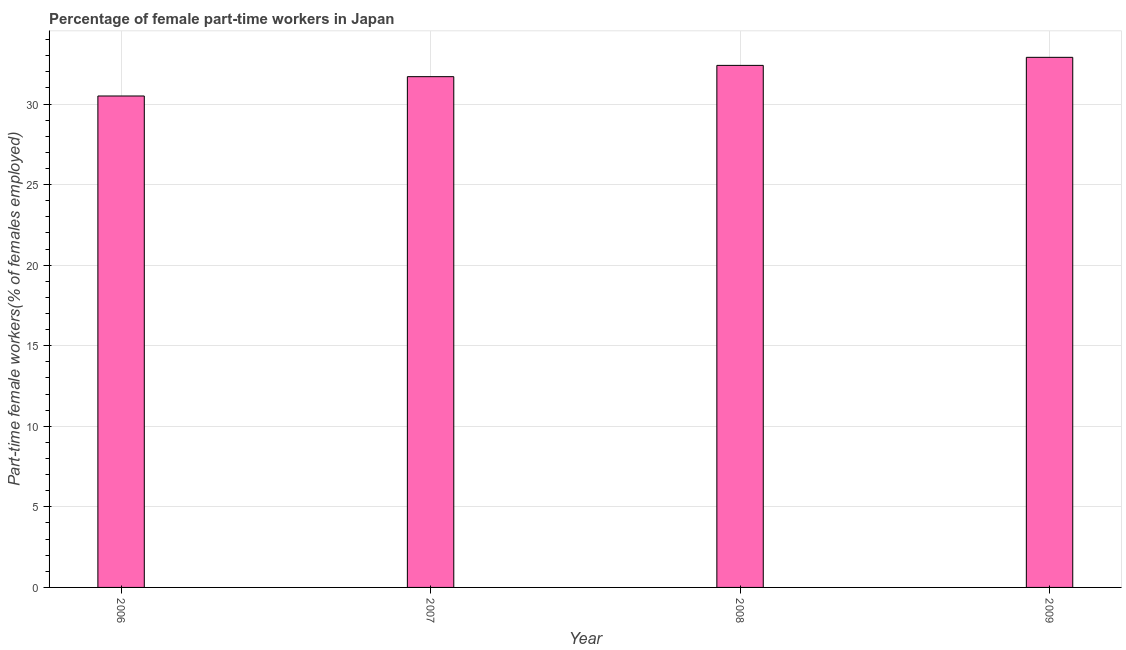Does the graph contain any zero values?
Make the answer very short. No. What is the title of the graph?
Ensure brevity in your answer.  Percentage of female part-time workers in Japan. What is the label or title of the X-axis?
Your answer should be compact. Year. What is the label or title of the Y-axis?
Offer a terse response. Part-time female workers(% of females employed). What is the percentage of part-time female workers in 2008?
Offer a very short reply. 32.4. Across all years, what is the maximum percentage of part-time female workers?
Keep it short and to the point. 32.9. Across all years, what is the minimum percentage of part-time female workers?
Give a very brief answer. 30.5. In which year was the percentage of part-time female workers minimum?
Your response must be concise. 2006. What is the sum of the percentage of part-time female workers?
Your response must be concise. 127.5. What is the average percentage of part-time female workers per year?
Keep it short and to the point. 31.88. What is the median percentage of part-time female workers?
Provide a short and direct response. 32.05. In how many years, is the percentage of part-time female workers greater than 27 %?
Offer a very short reply. 4. What is the difference between the highest and the second highest percentage of part-time female workers?
Your response must be concise. 0.5. Is the sum of the percentage of part-time female workers in 2006 and 2008 greater than the maximum percentage of part-time female workers across all years?
Give a very brief answer. Yes. What is the difference between the highest and the lowest percentage of part-time female workers?
Give a very brief answer. 2.4. In how many years, is the percentage of part-time female workers greater than the average percentage of part-time female workers taken over all years?
Provide a succinct answer. 2. How many bars are there?
Provide a succinct answer. 4. Are the values on the major ticks of Y-axis written in scientific E-notation?
Provide a short and direct response. No. What is the Part-time female workers(% of females employed) in 2006?
Provide a succinct answer. 30.5. What is the Part-time female workers(% of females employed) of 2007?
Make the answer very short. 31.7. What is the Part-time female workers(% of females employed) in 2008?
Offer a terse response. 32.4. What is the Part-time female workers(% of females employed) in 2009?
Your answer should be very brief. 32.9. What is the difference between the Part-time female workers(% of females employed) in 2006 and 2008?
Provide a short and direct response. -1.9. What is the difference between the Part-time female workers(% of females employed) in 2007 and 2008?
Offer a terse response. -0.7. What is the difference between the Part-time female workers(% of females employed) in 2007 and 2009?
Provide a succinct answer. -1.2. What is the difference between the Part-time female workers(% of females employed) in 2008 and 2009?
Your answer should be very brief. -0.5. What is the ratio of the Part-time female workers(% of females employed) in 2006 to that in 2008?
Offer a terse response. 0.94. What is the ratio of the Part-time female workers(% of females employed) in 2006 to that in 2009?
Keep it short and to the point. 0.93. What is the ratio of the Part-time female workers(% of females employed) in 2008 to that in 2009?
Provide a succinct answer. 0.98. 